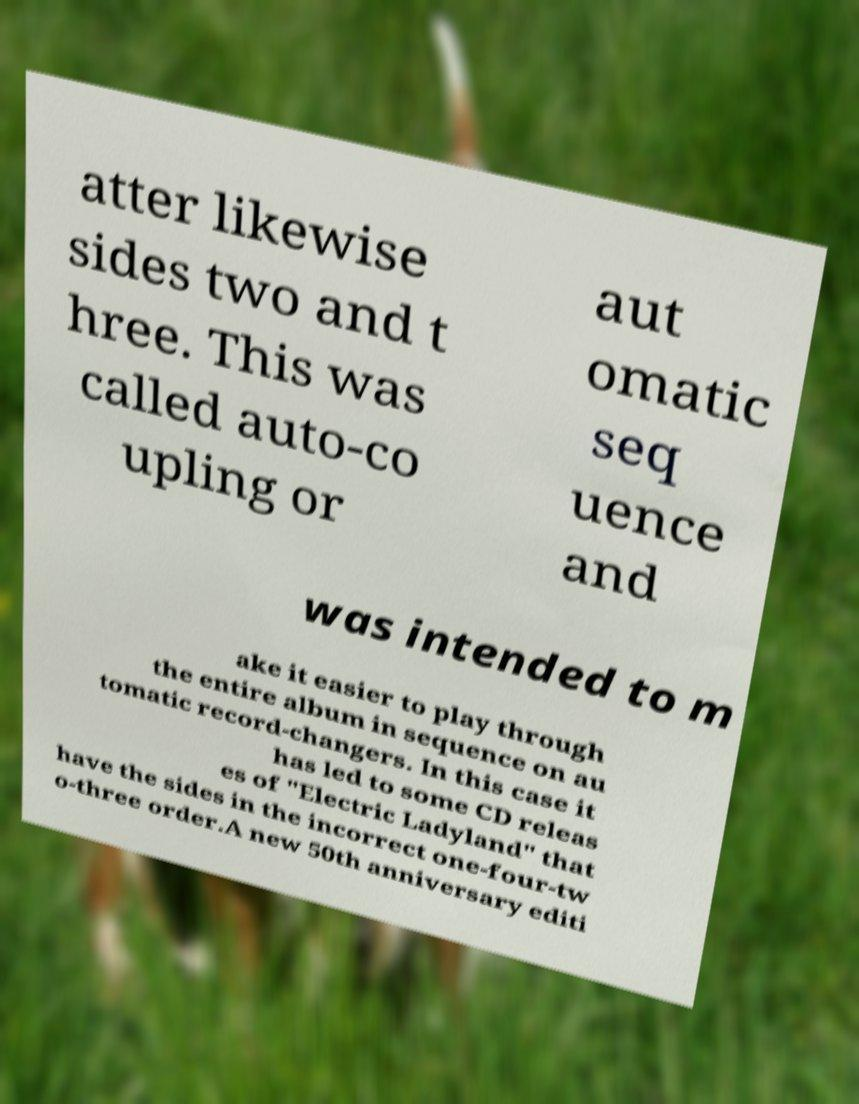For documentation purposes, I need the text within this image transcribed. Could you provide that? atter likewise sides two and t hree. This was called auto-co upling or aut omatic seq uence and was intended to m ake it easier to play through the entire album in sequence on au tomatic record-changers. In this case it has led to some CD releas es of "Electric Ladyland" that have the sides in the incorrect one-four-tw o-three order.A new 50th anniversary editi 